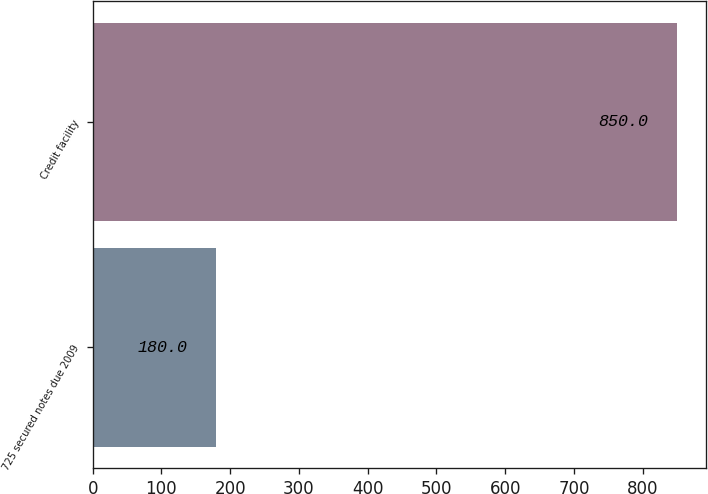Convert chart. <chart><loc_0><loc_0><loc_500><loc_500><bar_chart><fcel>725 secured notes due 2009<fcel>Credit facility<nl><fcel>180<fcel>850<nl></chart> 